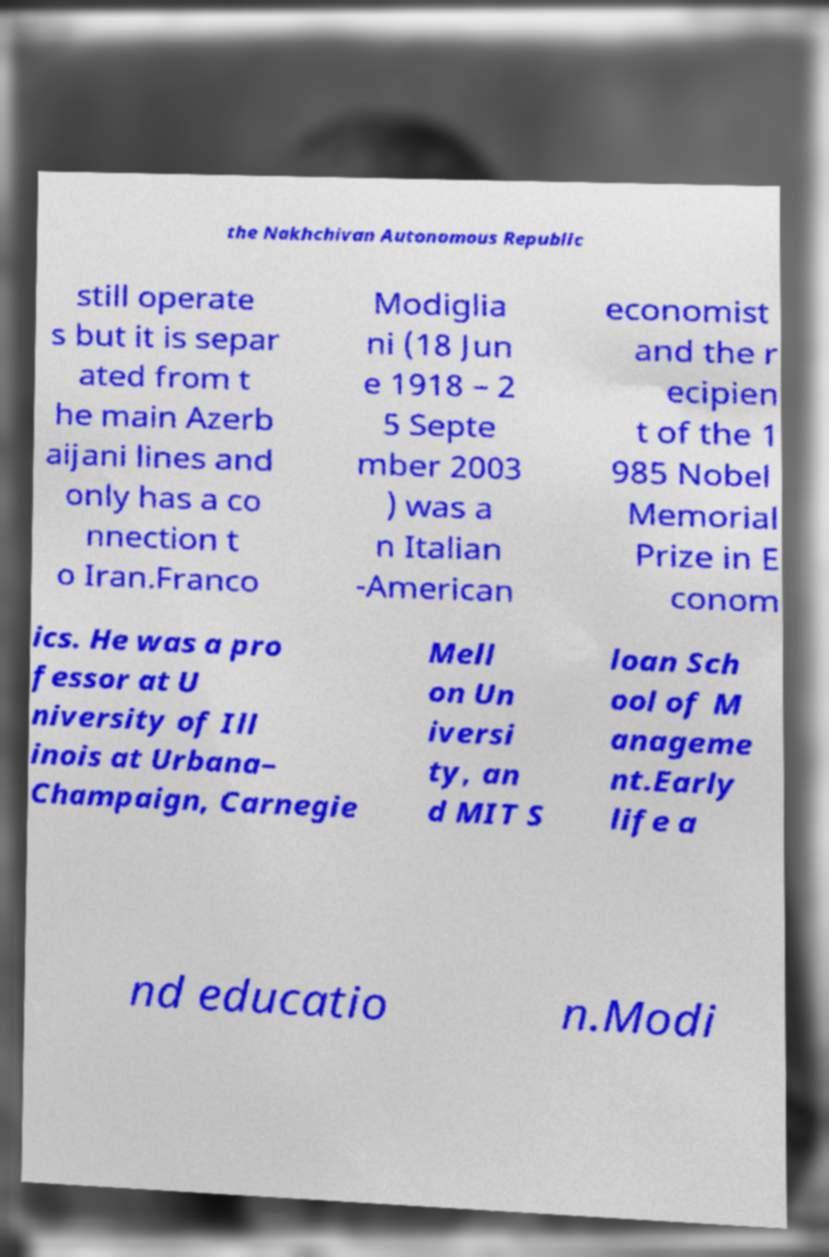There's text embedded in this image that I need extracted. Can you transcribe it verbatim? the Nakhchivan Autonomous Republic still operate s but it is separ ated from t he main Azerb aijani lines and only has a co nnection t o Iran.Franco Modiglia ni (18 Jun e 1918 – 2 5 Septe mber 2003 ) was a n Italian -American economist and the r ecipien t of the 1 985 Nobel Memorial Prize in E conom ics. He was a pro fessor at U niversity of Ill inois at Urbana– Champaign, Carnegie Mell on Un iversi ty, an d MIT S loan Sch ool of M anageme nt.Early life a nd educatio n.Modi 